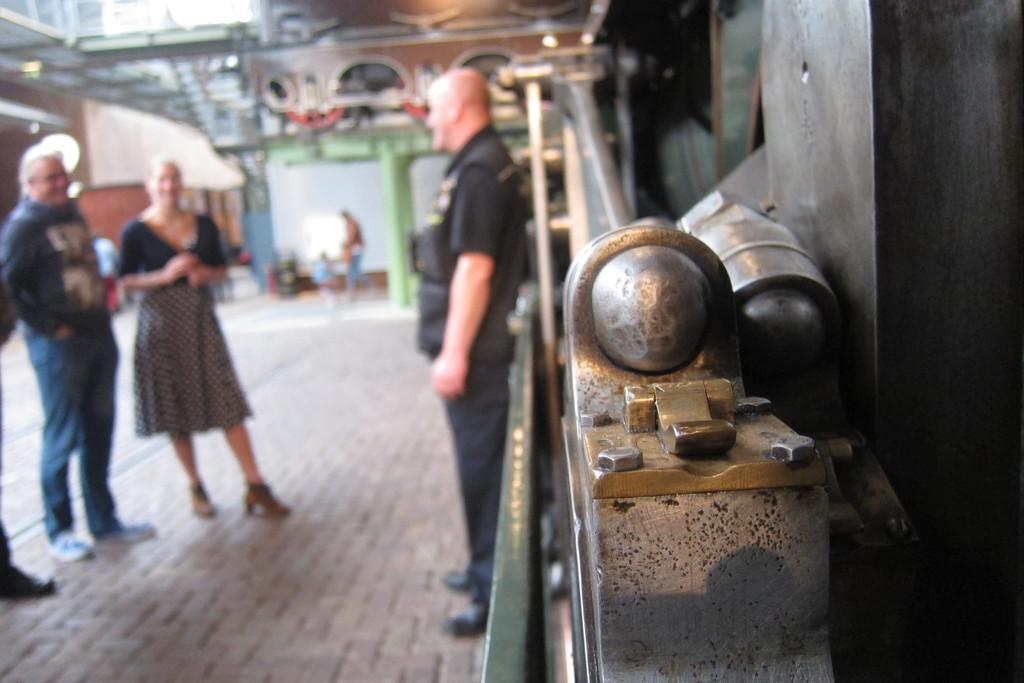What is happening in the image? There are people standing in the image. What can be seen on the right side of the image? There is an object on the right side of the image. Can you describe the background of the image? The background of the image is blurry. What type of cast can be seen on the person's arm in the image? There is no cast visible on anyone's arm in the image. What kind of needle is being used by the person in the image? There is no needle present in the image. 